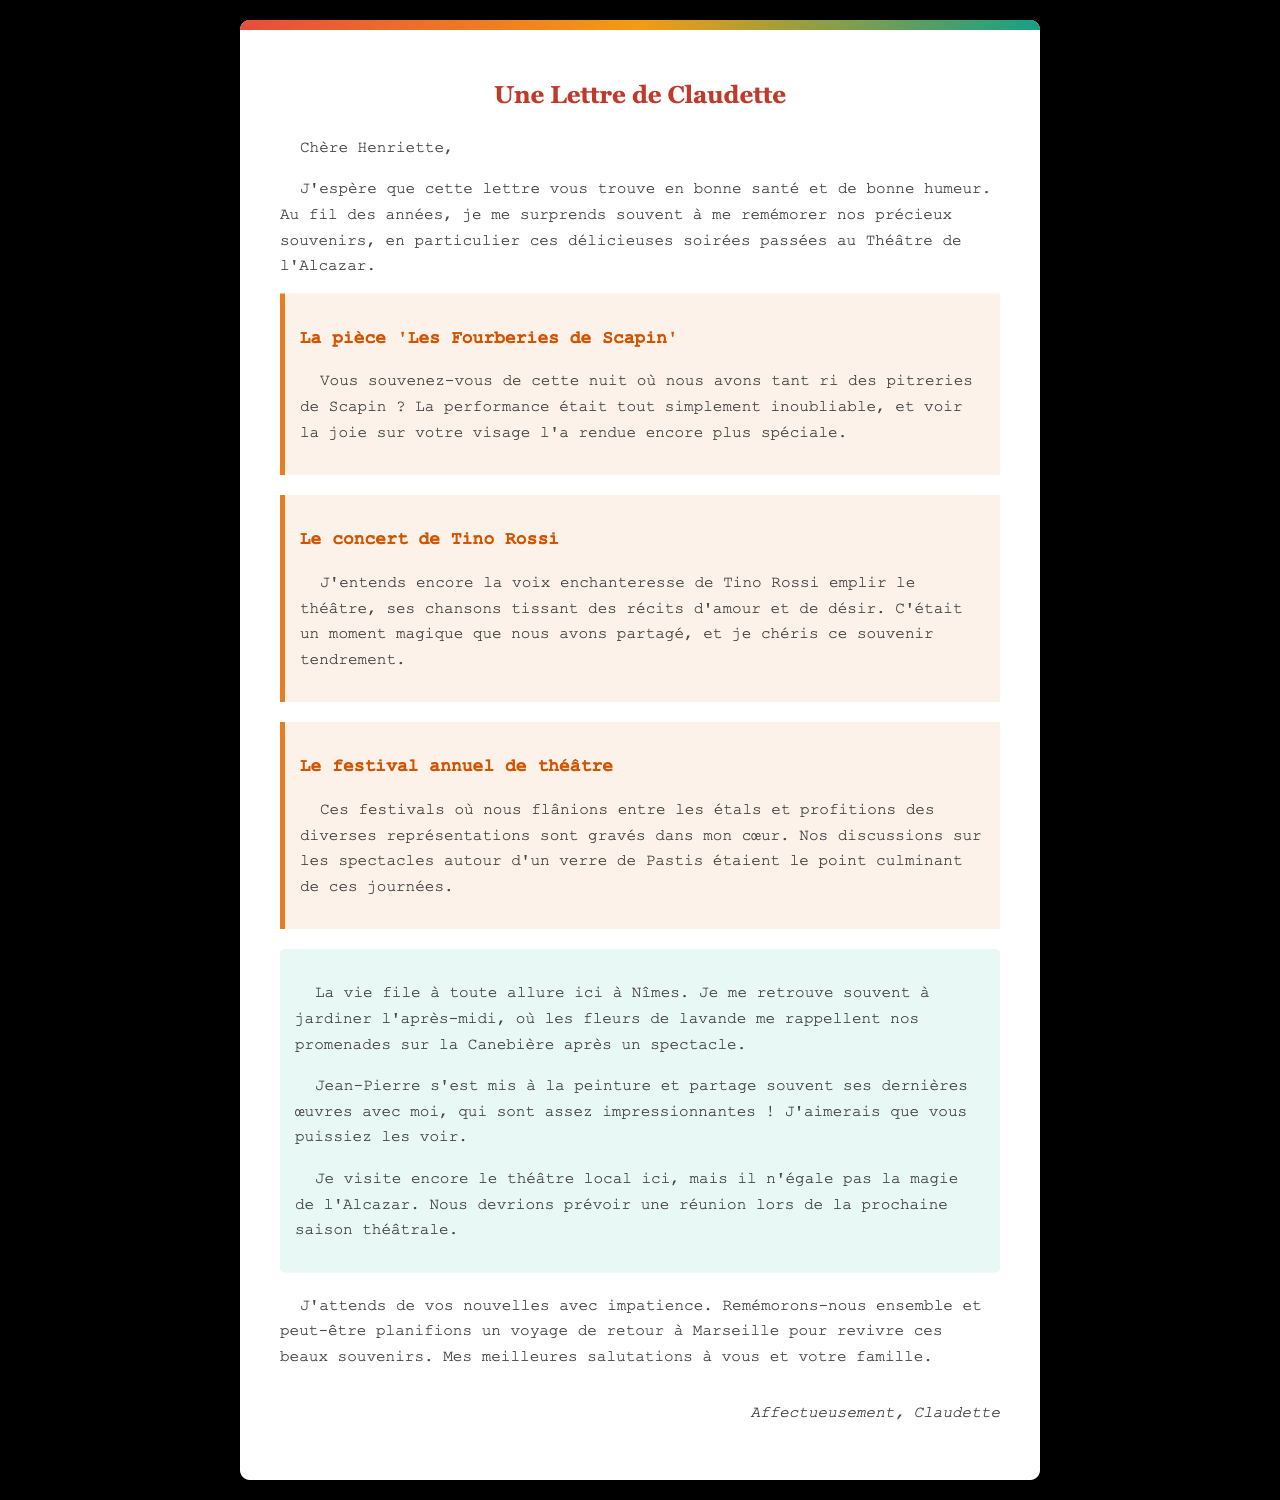Quelle est la première pièce mentionnée dans la lettre ? La première pièce évoquée dans la lettre est "Les Fourberies de Scapin".
Answer: Les Fourberies de Scapin Quel artiste a chanté pendant le concert dont Claudette se souvient ? Claudette se rappelle de la voix de Tino Rossi pendant le concert.
Answer: Tino Rossi Quelle ville Claudette mentionne-t-elle dans sa lettre ? Claudette écrit sa lettre depuis Nîmes.
Answer: Nîmes Quel est l'activité principale de Jean-Pierre mentionnée par Claudette ? Jean-Pierre s'est mis à la peinture.
Answer: La peinture Quel type de boisson est mentionné dans le souvenir des festivals ? Les personnages dans la lettre parlaient de boire un verre de Pastis.
Answer: Pastis Pourquoi Claudette trouve-t-elle les spectacles du théâtre local inférieurs ? Elle pense qu'aucun spectacle local n'égale la magie de l'Alcazar.
Answer: La magie de l'Alcazar Qui est le destinataire de la lettre ? La lettre est adressée à Henriette.
Answer: Henriette Quelle suggestion fait Claudette à la fin de sa lettre ? Elle propose de planifier un voyage de retour à Marseille.
Answer: Un voyage de retour à Marseille Combien de souvenirs partagent-elles de performances au Théâtre de l'Alcazar ? Il y a trois souvenirs évoqués dans la lettre.
Answer: Trois souvenirs 